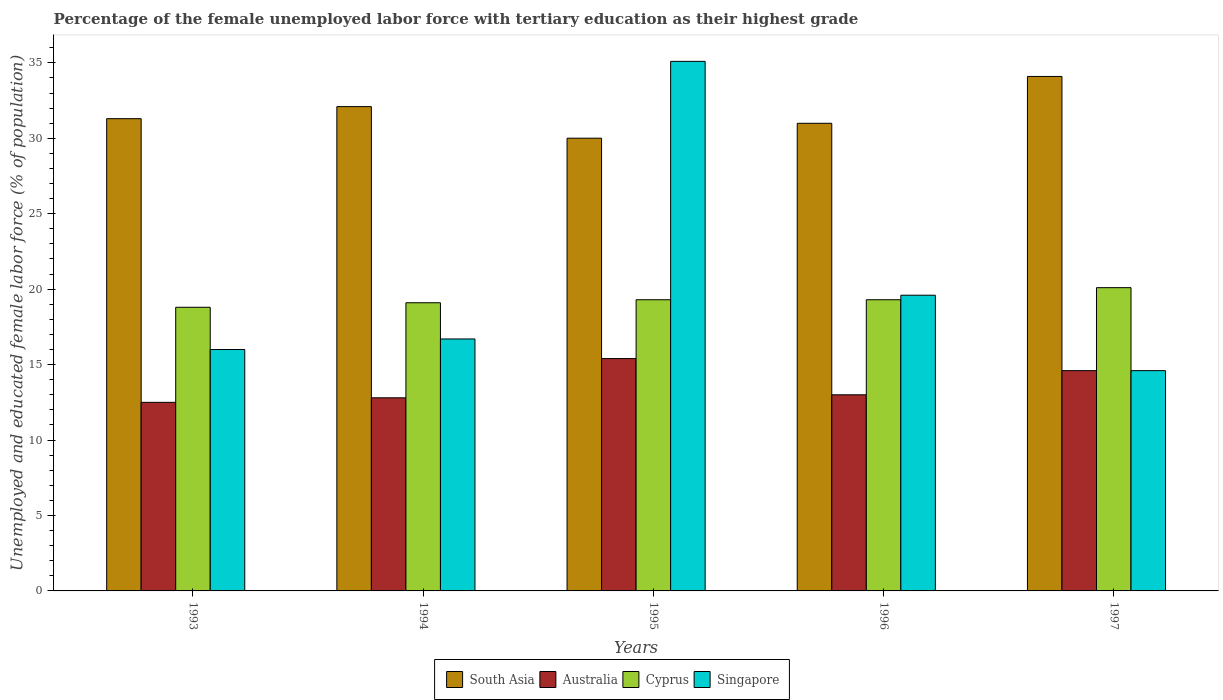Are the number of bars on each tick of the X-axis equal?
Ensure brevity in your answer.  Yes. How many bars are there on the 3rd tick from the left?
Ensure brevity in your answer.  4. How many bars are there on the 5th tick from the right?
Your answer should be very brief. 4. What is the label of the 2nd group of bars from the left?
Your answer should be very brief. 1994. What is the percentage of the unemployed female labor force with tertiary education in Australia in 1993?
Offer a terse response. 12.5. Across all years, what is the maximum percentage of the unemployed female labor force with tertiary education in Cyprus?
Make the answer very short. 20.1. Across all years, what is the minimum percentage of the unemployed female labor force with tertiary education in South Asia?
Give a very brief answer. 30.01. In which year was the percentage of the unemployed female labor force with tertiary education in Australia minimum?
Your response must be concise. 1993. What is the total percentage of the unemployed female labor force with tertiary education in Cyprus in the graph?
Keep it short and to the point. 96.6. What is the difference between the percentage of the unemployed female labor force with tertiary education in South Asia in 1995 and that in 1996?
Keep it short and to the point. -0.99. What is the difference between the percentage of the unemployed female labor force with tertiary education in South Asia in 1993 and the percentage of the unemployed female labor force with tertiary education in Singapore in 1997?
Your response must be concise. 16.7. What is the average percentage of the unemployed female labor force with tertiary education in South Asia per year?
Keep it short and to the point. 31.7. In the year 1997, what is the difference between the percentage of the unemployed female labor force with tertiary education in Cyprus and percentage of the unemployed female labor force with tertiary education in Australia?
Make the answer very short. 5.5. What is the ratio of the percentage of the unemployed female labor force with tertiary education in Australia in 1993 to that in 1996?
Provide a short and direct response. 0.96. Is the percentage of the unemployed female labor force with tertiary education in Cyprus in 1993 less than that in 1994?
Ensure brevity in your answer.  Yes. What is the difference between the highest and the second highest percentage of the unemployed female labor force with tertiary education in Australia?
Your answer should be very brief. 0.8. What is the difference between the highest and the lowest percentage of the unemployed female labor force with tertiary education in Australia?
Offer a very short reply. 2.9. Is it the case that in every year, the sum of the percentage of the unemployed female labor force with tertiary education in Singapore and percentage of the unemployed female labor force with tertiary education in South Asia is greater than the sum of percentage of the unemployed female labor force with tertiary education in Australia and percentage of the unemployed female labor force with tertiary education in Cyprus?
Give a very brief answer. Yes. What does the 3rd bar from the left in 1996 represents?
Ensure brevity in your answer.  Cyprus. What does the 2nd bar from the right in 1993 represents?
Your response must be concise. Cyprus. Is it the case that in every year, the sum of the percentage of the unemployed female labor force with tertiary education in South Asia and percentage of the unemployed female labor force with tertiary education in Australia is greater than the percentage of the unemployed female labor force with tertiary education in Cyprus?
Offer a very short reply. Yes. How many bars are there?
Ensure brevity in your answer.  20. Are all the bars in the graph horizontal?
Offer a very short reply. No. What is the difference between two consecutive major ticks on the Y-axis?
Provide a succinct answer. 5. Does the graph contain any zero values?
Offer a terse response. No. Does the graph contain grids?
Keep it short and to the point. No. How many legend labels are there?
Ensure brevity in your answer.  4. What is the title of the graph?
Give a very brief answer. Percentage of the female unemployed labor force with tertiary education as their highest grade. Does "Egypt, Arab Rep." appear as one of the legend labels in the graph?
Offer a very short reply. No. What is the label or title of the X-axis?
Offer a very short reply. Years. What is the label or title of the Y-axis?
Your answer should be compact. Unemployed and educated female labor force (% of population). What is the Unemployed and educated female labor force (% of population) of South Asia in 1993?
Provide a succinct answer. 31.3. What is the Unemployed and educated female labor force (% of population) of Cyprus in 1993?
Provide a succinct answer. 18.8. What is the Unemployed and educated female labor force (% of population) in South Asia in 1994?
Provide a short and direct response. 32.1. What is the Unemployed and educated female labor force (% of population) of Australia in 1994?
Your response must be concise. 12.8. What is the Unemployed and educated female labor force (% of population) of Cyprus in 1994?
Your answer should be very brief. 19.1. What is the Unemployed and educated female labor force (% of population) of Singapore in 1994?
Provide a succinct answer. 16.7. What is the Unemployed and educated female labor force (% of population) in South Asia in 1995?
Offer a very short reply. 30.01. What is the Unemployed and educated female labor force (% of population) of Australia in 1995?
Ensure brevity in your answer.  15.4. What is the Unemployed and educated female labor force (% of population) in Cyprus in 1995?
Provide a succinct answer. 19.3. What is the Unemployed and educated female labor force (% of population) in Singapore in 1995?
Offer a terse response. 35.1. What is the Unemployed and educated female labor force (% of population) in South Asia in 1996?
Give a very brief answer. 30.99. What is the Unemployed and educated female labor force (% of population) of Australia in 1996?
Keep it short and to the point. 13. What is the Unemployed and educated female labor force (% of population) in Cyprus in 1996?
Your answer should be compact. 19.3. What is the Unemployed and educated female labor force (% of population) of Singapore in 1996?
Offer a terse response. 19.6. What is the Unemployed and educated female labor force (% of population) in South Asia in 1997?
Ensure brevity in your answer.  34.1. What is the Unemployed and educated female labor force (% of population) of Australia in 1997?
Your answer should be very brief. 14.6. What is the Unemployed and educated female labor force (% of population) of Cyprus in 1997?
Ensure brevity in your answer.  20.1. What is the Unemployed and educated female labor force (% of population) of Singapore in 1997?
Make the answer very short. 14.6. Across all years, what is the maximum Unemployed and educated female labor force (% of population) of South Asia?
Keep it short and to the point. 34.1. Across all years, what is the maximum Unemployed and educated female labor force (% of population) in Australia?
Your response must be concise. 15.4. Across all years, what is the maximum Unemployed and educated female labor force (% of population) in Cyprus?
Make the answer very short. 20.1. Across all years, what is the maximum Unemployed and educated female labor force (% of population) of Singapore?
Offer a very short reply. 35.1. Across all years, what is the minimum Unemployed and educated female labor force (% of population) in South Asia?
Your answer should be compact. 30.01. Across all years, what is the minimum Unemployed and educated female labor force (% of population) in Cyprus?
Your response must be concise. 18.8. Across all years, what is the minimum Unemployed and educated female labor force (% of population) of Singapore?
Keep it short and to the point. 14.6. What is the total Unemployed and educated female labor force (% of population) of South Asia in the graph?
Make the answer very short. 158.5. What is the total Unemployed and educated female labor force (% of population) of Australia in the graph?
Make the answer very short. 68.3. What is the total Unemployed and educated female labor force (% of population) of Cyprus in the graph?
Give a very brief answer. 96.6. What is the total Unemployed and educated female labor force (% of population) of Singapore in the graph?
Your answer should be very brief. 102. What is the difference between the Unemployed and educated female labor force (% of population) of South Asia in 1993 and that in 1994?
Ensure brevity in your answer.  -0.8. What is the difference between the Unemployed and educated female labor force (% of population) of Australia in 1993 and that in 1994?
Offer a terse response. -0.3. What is the difference between the Unemployed and educated female labor force (% of population) in Cyprus in 1993 and that in 1994?
Offer a very short reply. -0.3. What is the difference between the Unemployed and educated female labor force (% of population) of South Asia in 1993 and that in 1995?
Offer a terse response. 1.29. What is the difference between the Unemployed and educated female labor force (% of population) of Australia in 1993 and that in 1995?
Give a very brief answer. -2.9. What is the difference between the Unemployed and educated female labor force (% of population) in Cyprus in 1993 and that in 1995?
Keep it short and to the point. -0.5. What is the difference between the Unemployed and educated female labor force (% of population) in Singapore in 1993 and that in 1995?
Offer a terse response. -19.1. What is the difference between the Unemployed and educated female labor force (% of population) of South Asia in 1993 and that in 1996?
Keep it short and to the point. 0.31. What is the difference between the Unemployed and educated female labor force (% of population) in South Asia in 1993 and that in 1997?
Provide a short and direct response. -2.8. What is the difference between the Unemployed and educated female labor force (% of population) in Australia in 1993 and that in 1997?
Offer a terse response. -2.1. What is the difference between the Unemployed and educated female labor force (% of population) of Cyprus in 1993 and that in 1997?
Provide a short and direct response. -1.3. What is the difference between the Unemployed and educated female labor force (% of population) of South Asia in 1994 and that in 1995?
Offer a terse response. 2.09. What is the difference between the Unemployed and educated female labor force (% of population) in Australia in 1994 and that in 1995?
Keep it short and to the point. -2.6. What is the difference between the Unemployed and educated female labor force (% of population) of Singapore in 1994 and that in 1995?
Provide a succinct answer. -18.4. What is the difference between the Unemployed and educated female labor force (% of population) in South Asia in 1994 and that in 1996?
Offer a very short reply. 1.11. What is the difference between the Unemployed and educated female labor force (% of population) of Australia in 1994 and that in 1996?
Give a very brief answer. -0.2. What is the difference between the Unemployed and educated female labor force (% of population) of South Asia in 1994 and that in 1997?
Your answer should be compact. -2. What is the difference between the Unemployed and educated female labor force (% of population) in Cyprus in 1994 and that in 1997?
Your answer should be compact. -1. What is the difference between the Unemployed and educated female labor force (% of population) in South Asia in 1995 and that in 1996?
Your answer should be very brief. -0.99. What is the difference between the Unemployed and educated female labor force (% of population) in Singapore in 1995 and that in 1996?
Make the answer very short. 15.5. What is the difference between the Unemployed and educated female labor force (% of population) of South Asia in 1995 and that in 1997?
Offer a terse response. -4.09. What is the difference between the Unemployed and educated female labor force (% of population) of Singapore in 1995 and that in 1997?
Give a very brief answer. 20.5. What is the difference between the Unemployed and educated female labor force (% of population) in South Asia in 1996 and that in 1997?
Offer a very short reply. -3.11. What is the difference between the Unemployed and educated female labor force (% of population) in Australia in 1996 and that in 1997?
Keep it short and to the point. -1.6. What is the difference between the Unemployed and educated female labor force (% of population) in South Asia in 1993 and the Unemployed and educated female labor force (% of population) in Australia in 1994?
Your response must be concise. 18.5. What is the difference between the Unemployed and educated female labor force (% of population) of South Asia in 1993 and the Unemployed and educated female labor force (% of population) of Singapore in 1994?
Provide a short and direct response. 14.6. What is the difference between the Unemployed and educated female labor force (% of population) in Australia in 1993 and the Unemployed and educated female labor force (% of population) in Cyprus in 1994?
Your response must be concise. -6.6. What is the difference between the Unemployed and educated female labor force (% of population) of Australia in 1993 and the Unemployed and educated female labor force (% of population) of Singapore in 1994?
Offer a very short reply. -4.2. What is the difference between the Unemployed and educated female labor force (% of population) of Cyprus in 1993 and the Unemployed and educated female labor force (% of population) of Singapore in 1994?
Make the answer very short. 2.1. What is the difference between the Unemployed and educated female labor force (% of population) of South Asia in 1993 and the Unemployed and educated female labor force (% of population) of Singapore in 1995?
Ensure brevity in your answer.  -3.8. What is the difference between the Unemployed and educated female labor force (% of population) of Australia in 1993 and the Unemployed and educated female labor force (% of population) of Singapore in 1995?
Your response must be concise. -22.6. What is the difference between the Unemployed and educated female labor force (% of population) in Cyprus in 1993 and the Unemployed and educated female labor force (% of population) in Singapore in 1995?
Provide a succinct answer. -16.3. What is the difference between the Unemployed and educated female labor force (% of population) of South Asia in 1993 and the Unemployed and educated female labor force (% of population) of Singapore in 1996?
Your answer should be very brief. 11.7. What is the difference between the Unemployed and educated female labor force (% of population) of Australia in 1993 and the Unemployed and educated female labor force (% of population) of Cyprus in 1996?
Offer a terse response. -6.8. What is the difference between the Unemployed and educated female labor force (% of population) of Australia in 1993 and the Unemployed and educated female labor force (% of population) of Singapore in 1996?
Your response must be concise. -7.1. What is the difference between the Unemployed and educated female labor force (% of population) in Cyprus in 1993 and the Unemployed and educated female labor force (% of population) in Singapore in 1996?
Make the answer very short. -0.8. What is the difference between the Unemployed and educated female labor force (% of population) of South Asia in 1993 and the Unemployed and educated female labor force (% of population) of Australia in 1997?
Provide a short and direct response. 16.7. What is the difference between the Unemployed and educated female labor force (% of population) of South Asia in 1993 and the Unemployed and educated female labor force (% of population) of Cyprus in 1997?
Keep it short and to the point. 11.2. What is the difference between the Unemployed and educated female labor force (% of population) in Australia in 1993 and the Unemployed and educated female labor force (% of population) in Cyprus in 1997?
Provide a succinct answer. -7.6. What is the difference between the Unemployed and educated female labor force (% of population) of Australia in 1993 and the Unemployed and educated female labor force (% of population) of Singapore in 1997?
Make the answer very short. -2.1. What is the difference between the Unemployed and educated female labor force (% of population) of South Asia in 1994 and the Unemployed and educated female labor force (% of population) of Singapore in 1995?
Your answer should be compact. -3. What is the difference between the Unemployed and educated female labor force (% of population) of Australia in 1994 and the Unemployed and educated female labor force (% of population) of Cyprus in 1995?
Offer a terse response. -6.5. What is the difference between the Unemployed and educated female labor force (% of population) in Australia in 1994 and the Unemployed and educated female labor force (% of population) in Singapore in 1995?
Give a very brief answer. -22.3. What is the difference between the Unemployed and educated female labor force (% of population) in South Asia in 1994 and the Unemployed and educated female labor force (% of population) in Australia in 1996?
Your answer should be very brief. 19.1. What is the difference between the Unemployed and educated female labor force (% of population) of South Asia in 1994 and the Unemployed and educated female labor force (% of population) of Cyprus in 1996?
Provide a short and direct response. 12.8. What is the difference between the Unemployed and educated female labor force (% of population) of Australia in 1994 and the Unemployed and educated female labor force (% of population) of Singapore in 1996?
Your answer should be very brief. -6.8. What is the difference between the Unemployed and educated female labor force (% of population) of South Asia in 1994 and the Unemployed and educated female labor force (% of population) of Cyprus in 1997?
Offer a terse response. 12. What is the difference between the Unemployed and educated female labor force (% of population) of South Asia in 1994 and the Unemployed and educated female labor force (% of population) of Singapore in 1997?
Provide a succinct answer. 17.5. What is the difference between the Unemployed and educated female labor force (% of population) of Australia in 1994 and the Unemployed and educated female labor force (% of population) of Cyprus in 1997?
Provide a succinct answer. -7.3. What is the difference between the Unemployed and educated female labor force (% of population) of Cyprus in 1994 and the Unemployed and educated female labor force (% of population) of Singapore in 1997?
Give a very brief answer. 4.5. What is the difference between the Unemployed and educated female labor force (% of population) in South Asia in 1995 and the Unemployed and educated female labor force (% of population) in Australia in 1996?
Offer a very short reply. 17.01. What is the difference between the Unemployed and educated female labor force (% of population) of South Asia in 1995 and the Unemployed and educated female labor force (% of population) of Cyprus in 1996?
Provide a succinct answer. 10.71. What is the difference between the Unemployed and educated female labor force (% of population) of South Asia in 1995 and the Unemployed and educated female labor force (% of population) of Singapore in 1996?
Offer a terse response. 10.41. What is the difference between the Unemployed and educated female labor force (% of population) of Australia in 1995 and the Unemployed and educated female labor force (% of population) of Cyprus in 1996?
Offer a terse response. -3.9. What is the difference between the Unemployed and educated female labor force (% of population) in Cyprus in 1995 and the Unemployed and educated female labor force (% of population) in Singapore in 1996?
Your answer should be compact. -0.3. What is the difference between the Unemployed and educated female labor force (% of population) in South Asia in 1995 and the Unemployed and educated female labor force (% of population) in Australia in 1997?
Your response must be concise. 15.41. What is the difference between the Unemployed and educated female labor force (% of population) of South Asia in 1995 and the Unemployed and educated female labor force (% of population) of Cyprus in 1997?
Your answer should be compact. 9.91. What is the difference between the Unemployed and educated female labor force (% of population) in South Asia in 1995 and the Unemployed and educated female labor force (% of population) in Singapore in 1997?
Give a very brief answer. 15.41. What is the difference between the Unemployed and educated female labor force (% of population) in Australia in 1995 and the Unemployed and educated female labor force (% of population) in Cyprus in 1997?
Provide a succinct answer. -4.7. What is the difference between the Unemployed and educated female labor force (% of population) in Australia in 1995 and the Unemployed and educated female labor force (% of population) in Singapore in 1997?
Provide a short and direct response. 0.8. What is the difference between the Unemployed and educated female labor force (% of population) in South Asia in 1996 and the Unemployed and educated female labor force (% of population) in Australia in 1997?
Your answer should be compact. 16.39. What is the difference between the Unemployed and educated female labor force (% of population) in South Asia in 1996 and the Unemployed and educated female labor force (% of population) in Cyprus in 1997?
Your answer should be compact. 10.89. What is the difference between the Unemployed and educated female labor force (% of population) of South Asia in 1996 and the Unemployed and educated female labor force (% of population) of Singapore in 1997?
Ensure brevity in your answer.  16.39. What is the difference between the Unemployed and educated female labor force (% of population) in Australia in 1996 and the Unemployed and educated female labor force (% of population) in Cyprus in 1997?
Ensure brevity in your answer.  -7.1. What is the difference between the Unemployed and educated female labor force (% of population) of Australia in 1996 and the Unemployed and educated female labor force (% of population) of Singapore in 1997?
Ensure brevity in your answer.  -1.6. What is the average Unemployed and educated female labor force (% of population) in South Asia per year?
Offer a terse response. 31.7. What is the average Unemployed and educated female labor force (% of population) in Australia per year?
Your response must be concise. 13.66. What is the average Unemployed and educated female labor force (% of population) of Cyprus per year?
Your response must be concise. 19.32. What is the average Unemployed and educated female labor force (% of population) in Singapore per year?
Your answer should be compact. 20.4. In the year 1993, what is the difference between the Unemployed and educated female labor force (% of population) of South Asia and Unemployed and educated female labor force (% of population) of Australia?
Offer a very short reply. 18.8. In the year 1993, what is the difference between the Unemployed and educated female labor force (% of population) of Australia and Unemployed and educated female labor force (% of population) of Cyprus?
Your response must be concise. -6.3. In the year 1993, what is the difference between the Unemployed and educated female labor force (% of population) in Cyprus and Unemployed and educated female labor force (% of population) in Singapore?
Offer a very short reply. 2.8. In the year 1994, what is the difference between the Unemployed and educated female labor force (% of population) in South Asia and Unemployed and educated female labor force (% of population) in Australia?
Give a very brief answer. 19.3. In the year 1994, what is the difference between the Unemployed and educated female labor force (% of population) of South Asia and Unemployed and educated female labor force (% of population) of Singapore?
Provide a succinct answer. 15.4. In the year 1994, what is the difference between the Unemployed and educated female labor force (% of population) of Australia and Unemployed and educated female labor force (% of population) of Singapore?
Keep it short and to the point. -3.9. In the year 1995, what is the difference between the Unemployed and educated female labor force (% of population) of South Asia and Unemployed and educated female labor force (% of population) of Australia?
Provide a succinct answer. 14.61. In the year 1995, what is the difference between the Unemployed and educated female labor force (% of population) of South Asia and Unemployed and educated female labor force (% of population) of Cyprus?
Give a very brief answer. 10.71. In the year 1995, what is the difference between the Unemployed and educated female labor force (% of population) in South Asia and Unemployed and educated female labor force (% of population) in Singapore?
Your answer should be compact. -5.09. In the year 1995, what is the difference between the Unemployed and educated female labor force (% of population) in Australia and Unemployed and educated female labor force (% of population) in Cyprus?
Your answer should be very brief. -3.9. In the year 1995, what is the difference between the Unemployed and educated female labor force (% of population) of Australia and Unemployed and educated female labor force (% of population) of Singapore?
Your answer should be very brief. -19.7. In the year 1995, what is the difference between the Unemployed and educated female labor force (% of population) in Cyprus and Unemployed and educated female labor force (% of population) in Singapore?
Give a very brief answer. -15.8. In the year 1996, what is the difference between the Unemployed and educated female labor force (% of population) in South Asia and Unemployed and educated female labor force (% of population) in Australia?
Offer a very short reply. 17.99. In the year 1996, what is the difference between the Unemployed and educated female labor force (% of population) of South Asia and Unemployed and educated female labor force (% of population) of Cyprus?
Keep it short and to the point. 11.69. In the year 1996, what is the difference between the Unemployed and educated female labor force (% of population) in South Asia and Unemployed and educated female labor force (% of population) in Singapore?
Keep it short and to the point. 11.39. In the year 1996, what is the difference between the Unemployed and educated female labor force (% of population) in Australia and Unemployed and educated female labor force (% of population) in Cyprus?
Offer a very short reply. -6.3. In the year 1996, what is the difference between the Unemployed and educated female labor force (% of population) of Cyprus and Unemployed and educated female labor force (% of population) of Singapore?
Keep it short and to the point. -0.3. In the year 1997, what is the difference between the Unemployed and educated female labor force (% of population) of South Asia and Unemployed and educated female labor force (% of population) of Australia?
Your answer should be very brief. 19.5. In the year 1997, what is the difference between the Unemployed and educated female labor force (% of population) in Australia and Unemployed and educated female labor force (% of population) in Cyprus?
Ensure brevity in your answer.  -5.5. What is the ratio of the Unemployed and educated female labor force (% of population) of South Asia in 1993 to that in 1994?
Provide a succinct answer. 0.98. What is the ratio of the Unemployed and educated female labor force (% of population) in Australia in 1993 to that in 1994?
Provide a short and direct response. 0.98. What is the ratio of the Unemployed and educated female labor force (% of population) in Cyprus in 1993 to that in 1994?
Provide a succinct answer. 0.98. What is the ratio of the Unemployed and educated female labor force (% of population) of Singapore in 1993 to that in 1994?
Ensure brevity in your answer.  0.96. What is the ratio of the Unemployed and educated female labor force (% of population) of South Asia in 1993 to that in 1995?
Your response must be concise. 1.04. What is the ratio of the Unemployed and educated female labor force (% of population) in Australia in 1993 to that in 1995?
Ensure brevity in your answer.  0.81. What is the ratio of the Unemployed and educated female labor force (% of population) in Cyprus in 1993 to that in 1995?
Your answer should be very brief. 0.97. What is the ratio of the Unemployed and educated female labor force (% of population) of Singapore in 1993 to that in 1995?
Offer a terse response. 0.46. What is the ratio of the Unemployed and educated female labor force (% of population) of South Asia in 1993 to that in 1996?
Make the answer very short. 1.01. What is the ratio of the Unemployed and educated female labor force (% of population) of Australia in 1993 to that in 1996?
Provide a short and direct response. 0.96. What is the ratio of the Unemployed and educated female labor force (% of population) of Cyprus in 1993 to that in 1996?
Your answer should be compact. 0.97. What is the ratio of the Unemployed and educated female labor force (% of population) of Singapore in 1993 to that in 1996?
Offer a terse response. 0.82. What is the ratio of the Unemployed and educated female labor force (% of population) in South Asia in 1993 to that in 1997?
Provide a succinct answer. 0.92. What is the ratio of the Unemployed and educated female labor force (% of population) in Australia in 1993 to that in 1997?
Your answer should be compact. 0.86. What is the ratio of the Unemployed and educated female labor force (% of population) of Cyprus in 1993 to that in 1997?
Your answer should be compact. 0.94. What is the ratio of the Unemployed and educated female labor force (% of population) in Singapore in 1993 to that in 1997?
Make the answer very short. 1.1. What is the ratio of the Unemployed and educated female labor force (% of population) in South Asia in 1994 to that in 1995?
Provide a short and direct response. 1.07. What is the ratio of the Unemployed and educated female labor force (% of population) of Australia in 1994 to that in 1995?
Offer a very short reply. 0.83. What is the ratio of the Unemployed and educated female labor force (% of population) in Cyprus in 1994 to that in 1995?
Provide a succinct answer. 0.99. What is the ratio of the Unemployed and educated female labor force (% of population) of Singapore in 1994 to that in 1995?
Provide a succinct answer. 0.48. What is the ratio of the Unemployed and educated female labor force (% of population) in South Asia in 1994 to that in 1996?
Provide a short and direct response. 1.04. What is the ratio of the Unemployed and educated female labor force (% of population) of Australia in 1994 to that in 1996?
Make the answer very short. 0.98. What is the ratio of the Unemployed and educated female labor force (% of population) in Cyprus in 1994 to that in 1996?
Offer a terse response. 0.99. What is the ratio of the Unemployed and educated female labor force (% of population) of Singapore in 1994 to that in 1996?
Give a very brief answer. 0.85. What is the ratio of the Unemployed and educated female labor force (% of population) in South Asia in 1994 to that in 1997?
Provide a succinct answer. 0.94. What is the ratio of the Unemployed and educated female labor force (% of population) of Australia in 1994 to that in 1997?
Your answer should be compact. 0.88. What is the ratio of the Unemployed and educated female labor force (% of population) in Cyprus in 1994 to that in 1997?
Your answer should be compact. 0.95. What is the ratio of the Unemployed and educated female labor force (% of population) of Singapore in 1994 to that in 1997?
Provide a short and direct response. 1.14. What is the ratio of the Unemployed and educated female labor force (% of population) in South Asia in 1995 to that in 1996?
Your answer should be very brief. 0.97. What is the ratio of the Unemployed and educated female labor force (% of population) in Australia in 1995 to that in 1996?
Your answer should be very brief. 1.18. What is the ratio of the Unemployed and educated female labor force (% of population) of Cyprus in 1995 to that in 1996?
Ensure brevity in your answer.  1. What is the ratio of the Unemployed and educated female labor force (% of population) of Singapore in 1995 to that in 1996?
Make the answer very short. 1.79. What is the ratio of the Unemployed and educated female labor force (% of population) in Australia in 1995 to that in 1997?
Offer a very short reply. 1.05. What is the ratio of the Unemployed and educated female labor force (% of population) of Cyprus in 1995 to that in 1997?
Provide a succinct answer. 0.96. What is the ratio of the Unemployed and educated female labor force (% of population) of Singapore in 1995 to that in 1997?
Your answer should be compact. 2.4. What is the ratio of the Unemployed and educated female labor force (% of population) in South Asia in 1996 to that in 1997?
Ensure brevity in your answer.  0.91. What is the ratio of the Unemployed and educated female labor force (% of population) in Australia in 1996 to that in 1997?
Your answer should be very brief. 0.89. What is the ratio of the Unemployed and educated female labor force (% of population) in Cyprus in 1996 to that in 1997?
Provide a succinct answer. 0.96. What is the ratio of the Unemployed and educated female labor force (% of population) of Singapore in 1996 to that in 1997?
Your response must be concise. 1.34. What is the difference between the highest and the second highest Unemployed and educated female labor force (% of population) in Cyprus?
Provide a short and direct response. 0.8. What is the difference between the highest and the lowest Unemployed and educated female labor force (% of population) of South Asia?
Your answer should be compact. 4.09. What is the difference between the highest and the lowest Unemployed and educated female labor force (% of population) of Singapore?
Provide a short and direct response. 20.5. 